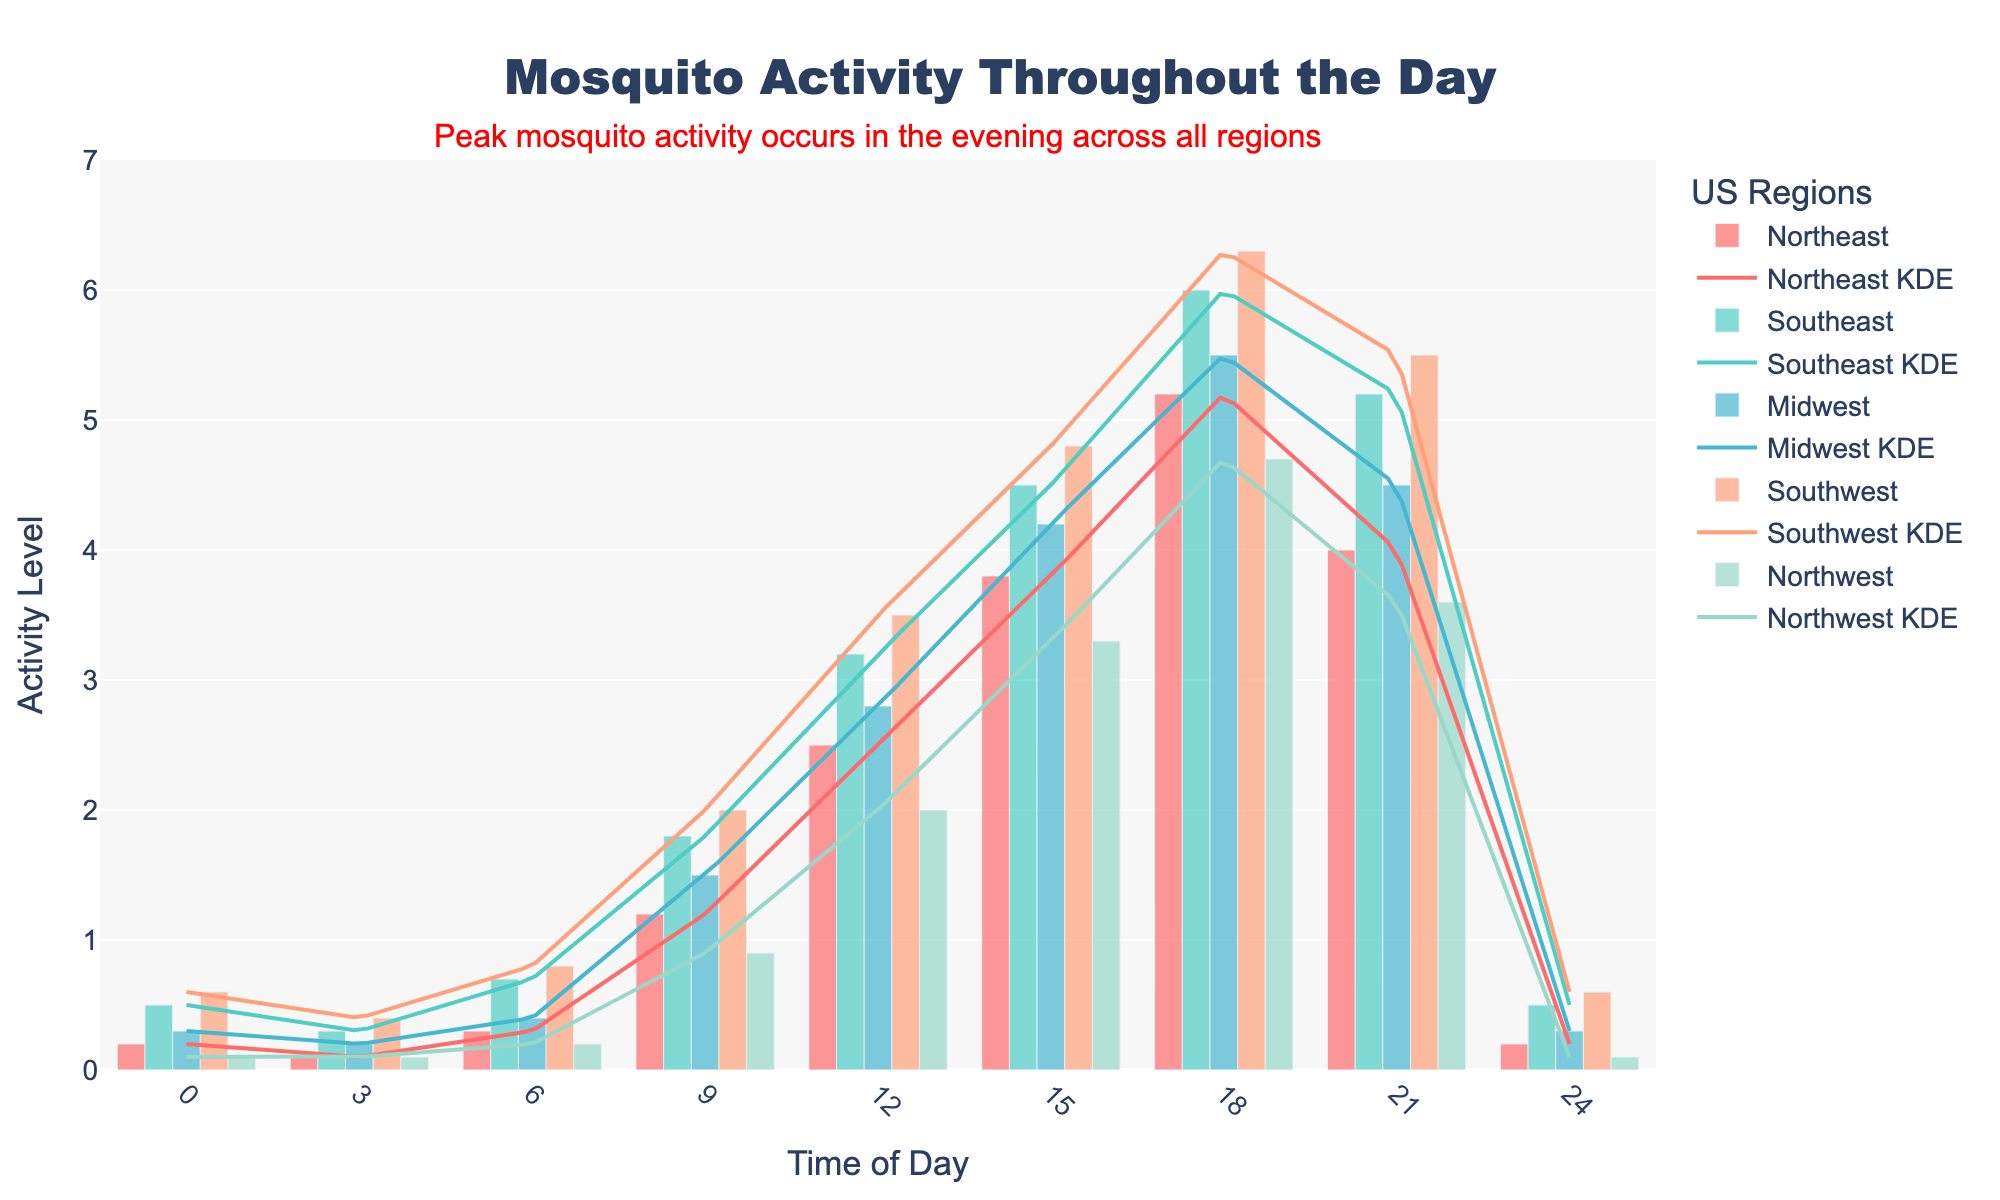What is the title of the plot? The title of the plot is usually displayed at the top in a larger and bold font. Here, the title is centered and reads "Mosquito Activity Throughout the Day".
Answer: Mosquito Activity Throughout the Day Which region shows the highest peak in mosquito activity? By looking at the peak values of the histograms and density curves for each region, the Southwest region reaches the highest activity level at approximately 6.3.
Answer: Southwest At what time of day does the Northeast region reach its highest activity? Observing the histogram bars and KDE curve for the Northeast region, the highest activity is at 18:00 or 6 PM.
Answer: 18:00 How does mosquito activity at 3:00 compare between the Midwest and Southeast regions? Comparing the histogram bars for the two regions at the 3:00 time point, the Midwest has a lower activity level of 0.2 compared to the Southeast's 0.3.
Answer: Southeast has higher activity What is the trend of mosquito activity in the Northwest region from 9:00 to 18:00? The histogram and KDE curve for the Northwest region show a gradual increase in mosquito activity starting from 9:00 and peaking at 18:00 before decreasing at 21:00.
Answer: Gradually increases up to 18:00 Which region has the lowest mosquito activity at 6:00? By comparing the histogram bars at the 6:00 time interval, the Northwest region has the lowest activity with a level of 0.2.
Answer: Northwest What is the average mosquito activity level at 21:00 across all regions? Summing up the activity levels of all regions at 21:00 (4 + 5.2 + 4.5 + 5.5 + 3.6 = 22.8) and then dividing by the number of regions (5) gives the average (22.8/5 = 4.56).
Answer: 4.56 At what time does the Southeast region's mosquito activity start to significantly increase? Observing the histogram and KDE for the Southeast region, there is a noticeable increase in activity starting from 6:00.
Answer: 6:00 Which two regions have a similar pattern of mosquito activity throughout the day? Comparing the shapes of the histograms and KDE curves, the Southeast and Southwest regions follow a similar pattern of activity levels.
Answer: Southeast and Southwest What is the activity level for the Midwest at 15:00, and how does it compare to the Southwest at the same time? Checking the histogram bars, the Midwest has an activity level of 4.2 at 15:00, while the Southwest has a higher level of 4.8.
Answer: Midwest: 4.2, Southwest: 4.8 